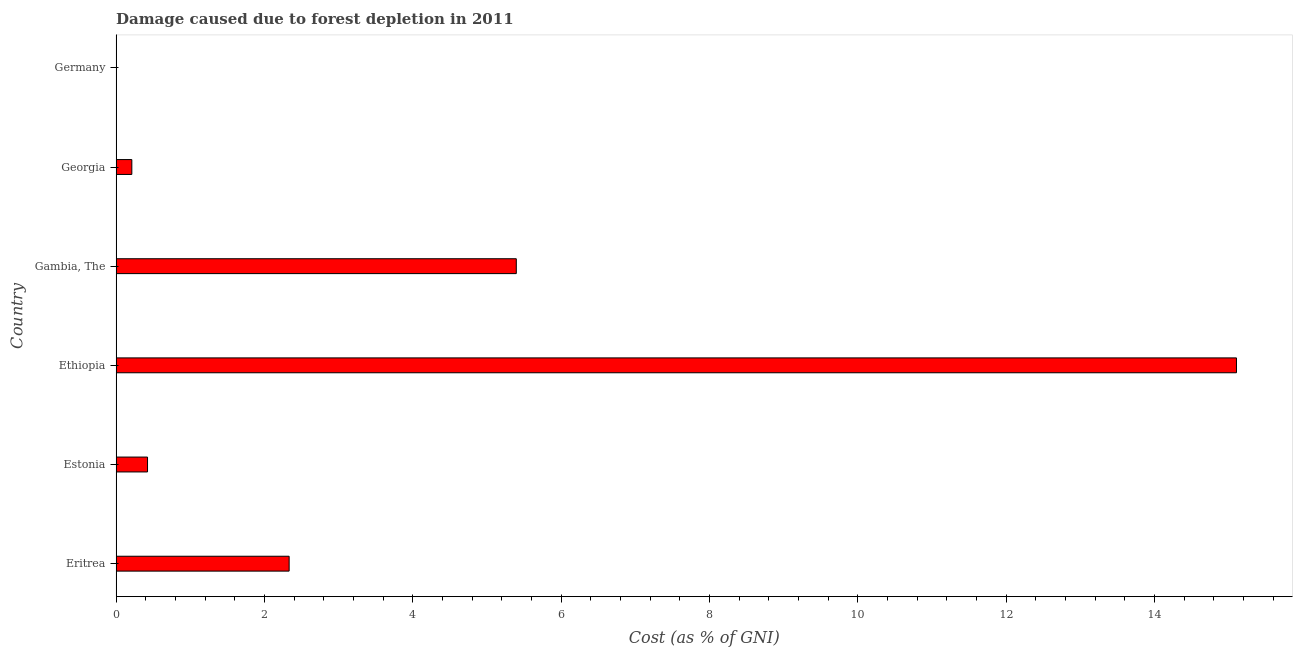Does the graph contain any zero values?
Make the answer very short. No. Does the graph contain grids?
Provide a short and direct response. No. What is the title of the graph?
Provide a succinct answer. Damage caused due to forest depletion in 2011. What is the label or title of the X-axis?
Keep it short and to the point. Cost (as % of GNI). What is the label or title of the Y-axis?
Provide a succinct answer. Country. What is the damage caused due to forest depletion in Eritrea?
Give a very brief answer. 2.33. Across all countries, what is the maximum damage caused due to forest depletion?
Make the answer very short. 15.11. Across all countries, what is the minimum damage caused due to forest depletion?
Provide a succinct answer. 0. In which country was the damage caused due to forest depletion maximum?
Give a very brief answer. Ethiopia. In which country was the damage caused due to forest depletion minimum?
Ensure brevity in your answer.  Germany. What is the sum of the damage caused due to forest depletion?
Make the answer very short. 23.47. What is the difference between the damage caused due to forest depletion in Ethiopia and Germany?
Your response must be concise. 15.1. What is the average damage caused due to forest depletion per country?
Ensure brevity in your answer.  3.91. What is the median damage caused due to forest depletion?
Ensure brevity in your answer.  1.38. In how many countries, is the damage caused due to forest depletion greater than 14.4 %?
Your response must be concise. 1. What is the ratio of the damage caused due to forest depletion in Eritrea to that in Georgia?
Keep it short and to the point. 11.02. Is the difference between the damage caused due to forest depletion in Eritrea and Estonia greater than the difference between any two countries?
Make the answer very short. No. What is the difference between the highest and the second highest damage caused due to forest depletion?
Your response must be concise. 9.71. In how many countries, is the damage caused due to forest depletion greater than the average damage caused due to forest depletion taken over all countries?
Provide a succinct answer. 2. How many bars are there?
Your answer should be very brief. 6. Are all the bars in the graph horizontal?
Your answer should be compact. Yes. Are the values on the major ticks of X-axis written in scientific E-notation?
Offer a terse response. No. What is the Cost (as % of GNI) in Eritrea?
Keep it short and to the point. 2.33. What is the Cost (as % of GNI) in Estonia?
Provide a short and direct response. 0.42. What is the Cost (as % of GNI) in Ethiopia?
Your answer should be compact. 15.11. What is the Cost (as % of GNI) in Gambia, The?
Offer a terse response. 5.4. What is the Cost (as % of GNI) of Georgia?
Provide a short and direct response. 0.21. What is the Cost (as % of GNI) in Germany?
Your response must be concise. 0. What is the difference between the Cost (as % of GNI) in Eritrea and Estonia?
Your answer should be compact. 1.91. What is the difference between the Cost (as % of GNI) in Eritrea and Ethiopia?
Make the answer very short. -12.77. What is the difference between the Cost (as % of GNI) in Eritrea and Gambia, The?
Your answer should be compact. -3.06. What is the difference between the Cost (as % of GNI) in Eritrea and Georgia?
Make the answer very short. 2.12. What is the difference between the Cost (as % of GNI) in Eritrea and Germany?
Provide a short and direct response. 2.33. What is the difference between the Cost (as % of GNI) in Estonia and Ethiopia?
Provide a short and direct response. -14.68. What is the difference between the Cost (as % of GNI) in Estonia and Gambia, The?
Keep it short and to the point. -4.97. What is the difference between the Cost (as % of GNI) in Estonia and Georgia?
Keep it short and to the point. 0.21. What is the difference between the Cost (as % of GNI) in Estonia and Germany?
Provide a succinct answer. 0.42. What is the difference between the Cost (as % of GNI) in Ethiopia and Gambia, The?
Offer a very short reply. 9.71. What is the difference between the Cost (as % of GNI) in Ethiopia and Georgia?
Your answer should be compact. 14.89. What is the difference between the Cost (as % of GNI) in Ethiopia and Germany?
Provide a succinct answer. 15.1. What is the difference between the Cost (as % of GNI) in Gambia, The and Georgia?
Provide a succinct answer. 5.18. What is the difference between the Cost (as % of GNI) in Gambia, The and Germany?
Offer a terse response. 5.39. What is the difference between the Cost (as % of GNI) in Georgia and Germany?
Offer a terse response. 0.21. What is the ratio of the Cost (as % of GNI) in Eritrea to that in Estonia?
Provide a succinct answer. 5.51. What is the ratio of the Cost (as % of GNI) in Eritrea to that in Ethiopia?
Your response must be concise. 0.15. What is the ratio of the Cost (as % of GNI) in Eritrea to that in Gambia, The?
Offer a very short reply. 0.43. What is the ratio of the Cost (as % of GNI) in Eritrea to that in Georgia?
Offer a terse response. 11.02. What is the ratio of the Cost (as % of GNI) in Eritrea to that in Germany?
Your answer should be very brief. 1179.23. What is the ratio of the Cost (as % of GNI) in Estonia to that in Ethiopia?
Ensure brevity in your answer.  0.03. What is the ratio of the Cost (as % of GNI) in Estonia to that in Gambia, The?
Offer a very short reply. 0.08. What is the ratio of the Cost (as % of GNI) in Estonia to that in Germany?
Your answer should be compact. 214.08. What is the ratio of the Cost (as % of GNI) in Ethiopia to that in Georgia?
Offer a very short reply. 71.34. What is the ratio of the Cost (as % of GNI) in Ethiopia to that in Germany?
Provide a succinct answer. 7636.41. What is the ratio of the Cost (as % of GNI) in Gambia, The to that in Georgia?
Offer a terse response. 25.48. What is the ratio of the Cost (as % of GNI) in Gambia, The to that in Germany?
Offer a very short reply. 2727.58. What is the ratio of the Cost (as % of GNI) in Georgia to that in Germany?
Your answer should be compact. 107.04. 